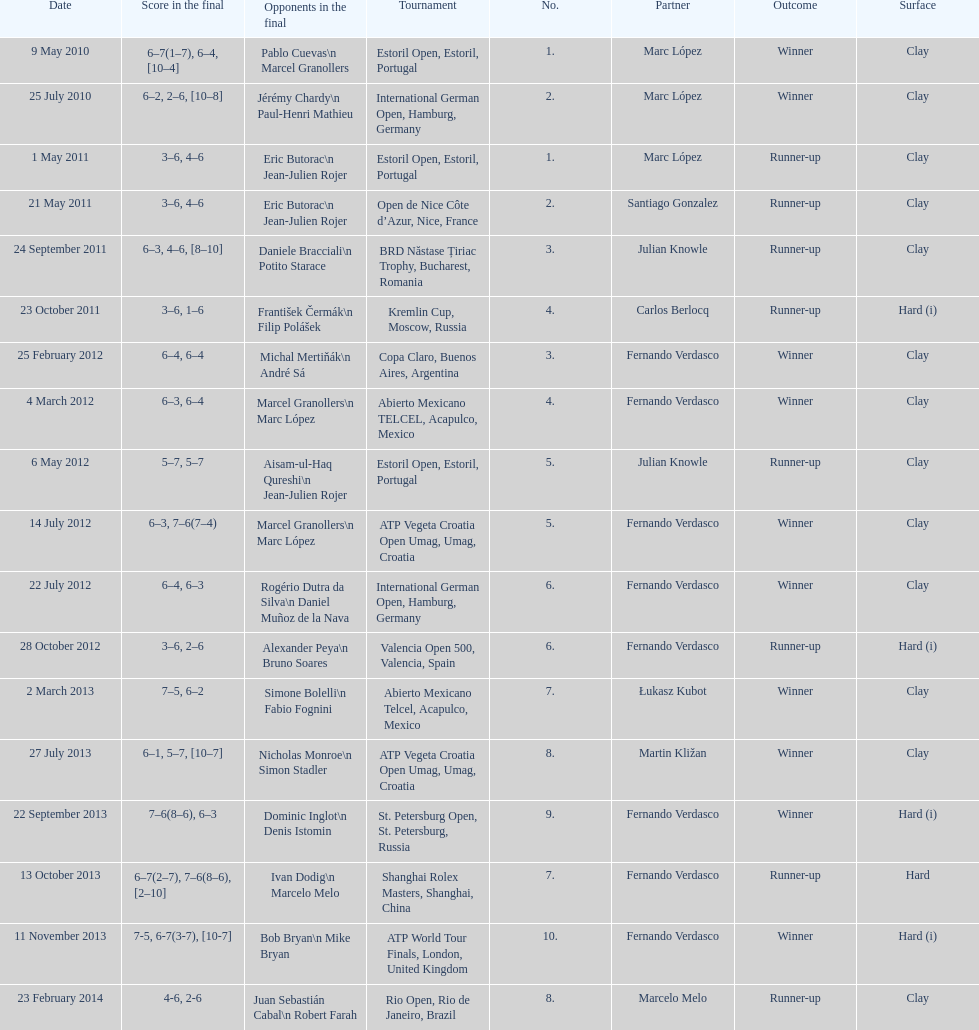Who won both the st.petersburg open and the atp world tour finals? Fernando Verdasco. 